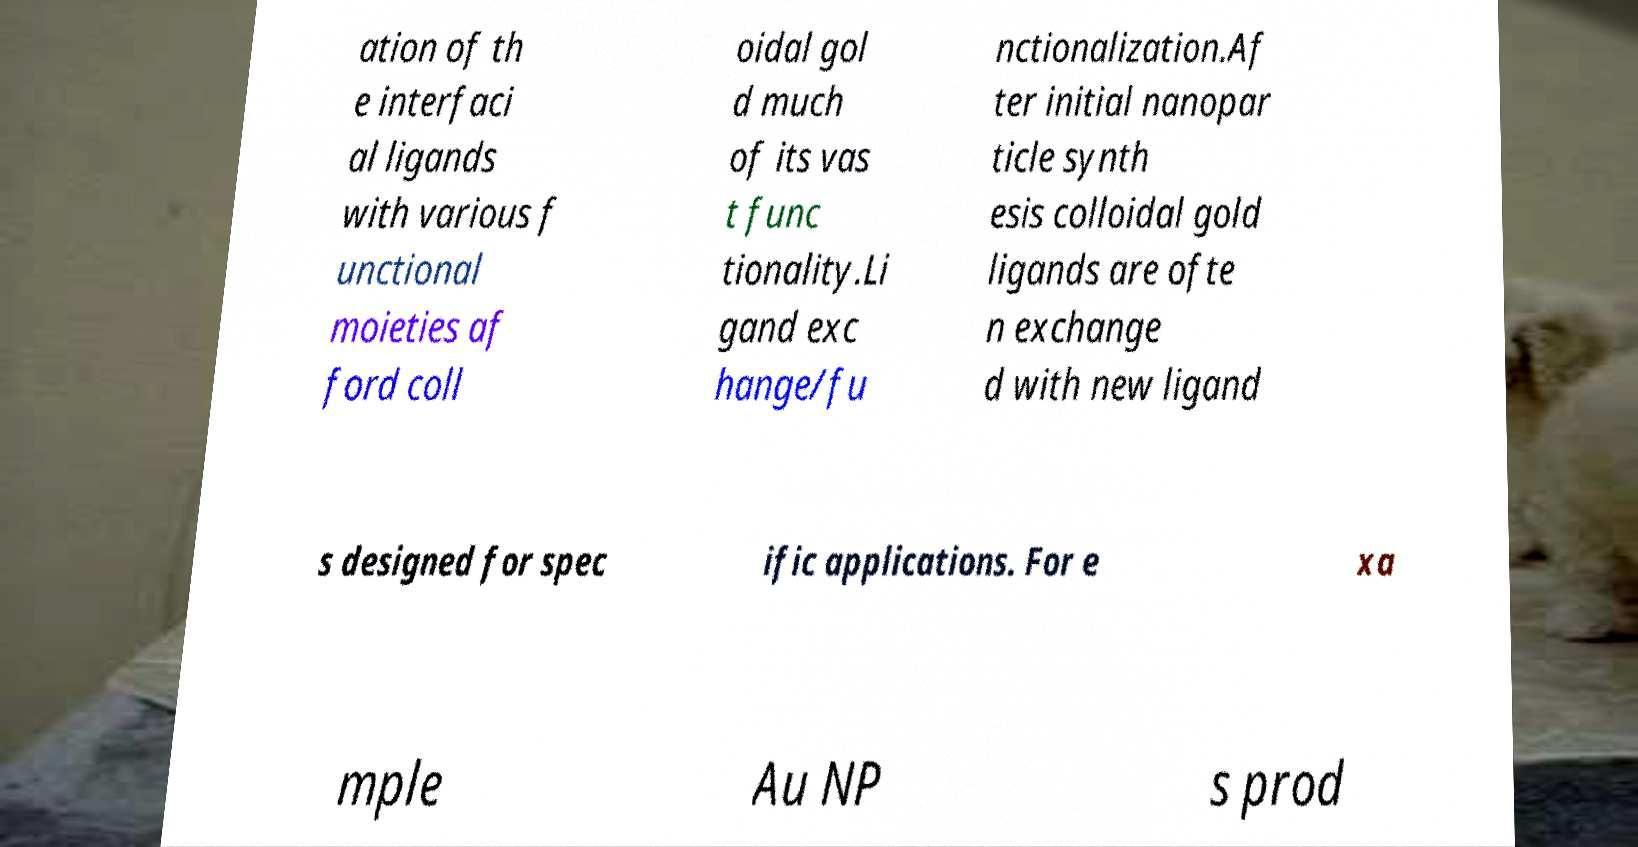I need the written content from this picture converted into text. Can you do that? ation of th e interfaci al ligands with various f unctional moieties af ford coll oidal gol d much of its vas t func tionality.Li gand exc hange/fu nctionalization.Af ter initial nanopar ticle synth esis colloidal gold ligands are ofte n exchange d with new ligand s designed for spec ific applications. For e xa mple Au NP s prod 